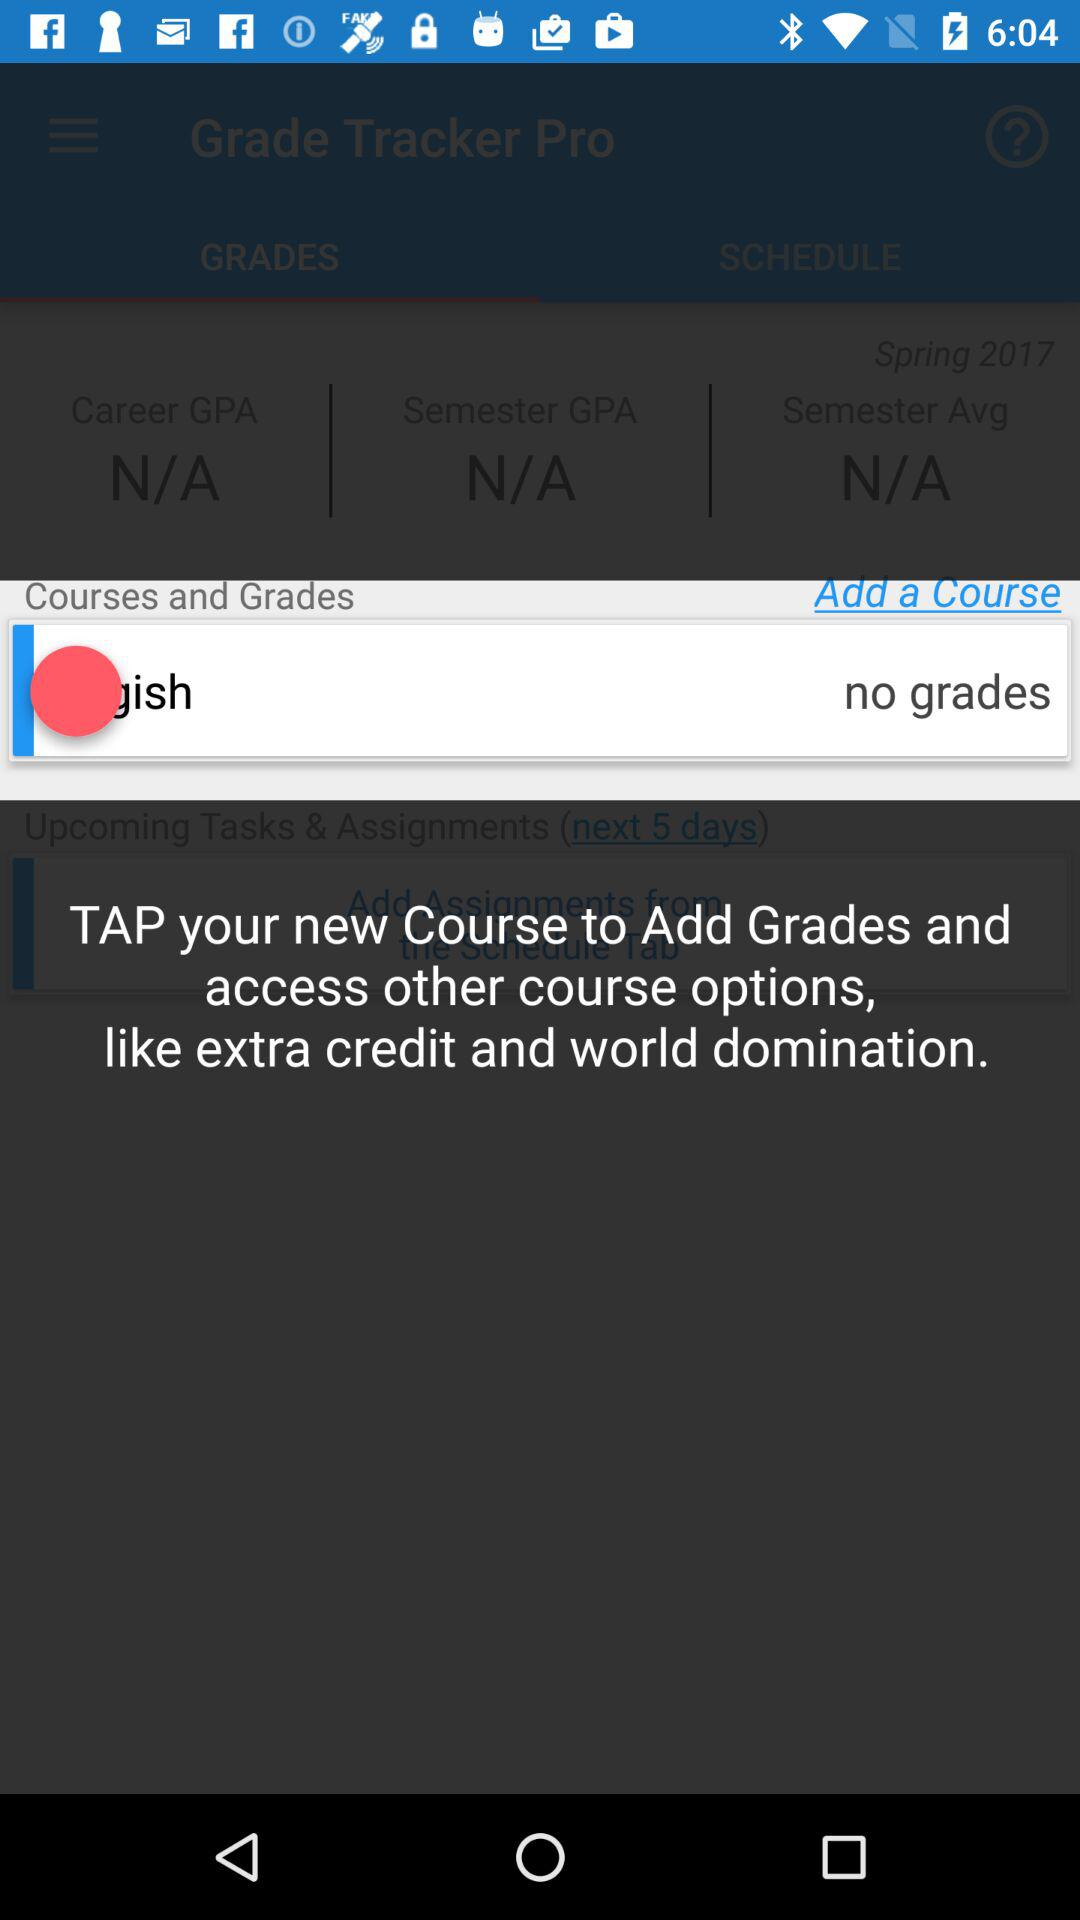What is the GPA for this semester?
Answer the question using a single word or phrase. N/A 